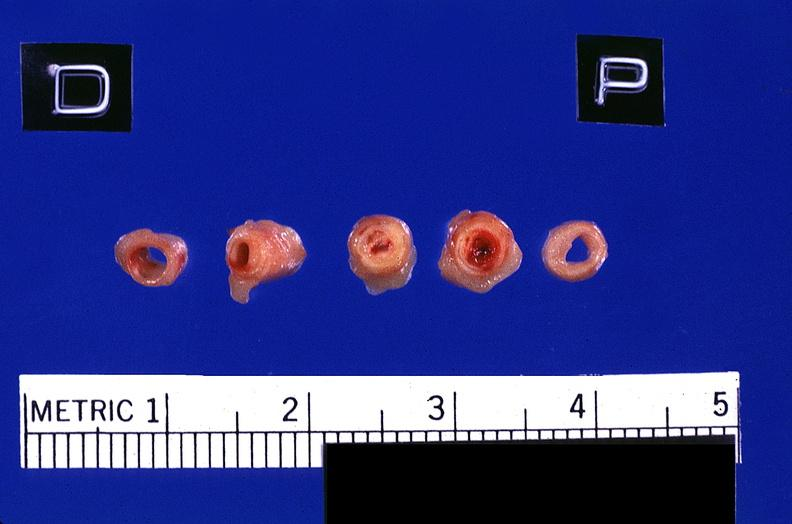s cardiovascular present?
Answer the question using a single word or phrase. Yes 